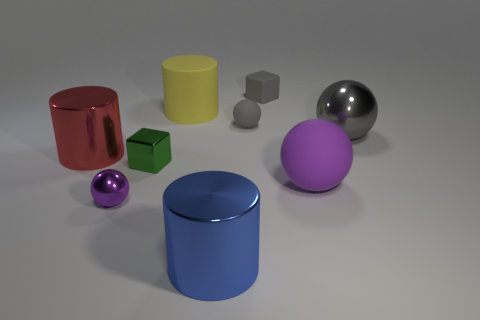The rubber object that is in front of the large metallic sphere has what shape? The rubber object positioned in front of the large metallic sphere is a cylinder. 